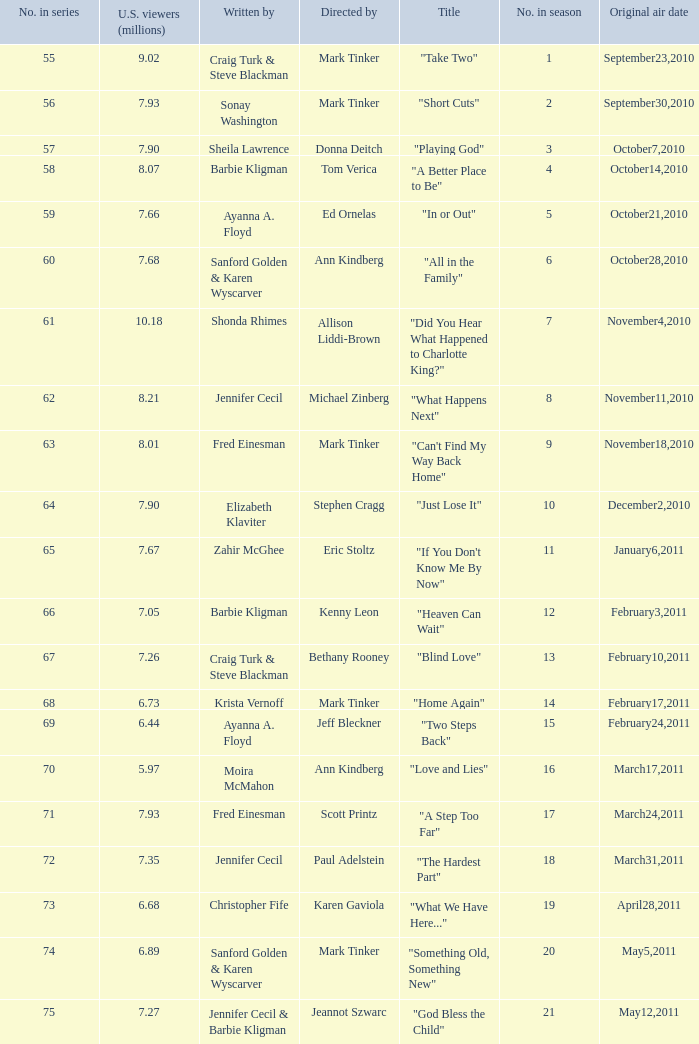What is the earliest numbered episode of the season? 1.0. 